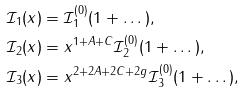Convert formula to latex. <formula><loc_0><loc_0><loc_500><loc_500>\mathcal { I } _ { 1 } ( x ) & = \mathcal { I } _ { 1 } ^ { ( 0 ) } ( 1 + \dots ) , \\ \mathcal { I } _ { 2 } ( x ) & = x ^ { 1 + A + C } \mathcal { I } _ { 2 } ^ { ( 0 ) } ( 1 + \dots ) , \\ \mathcal { I } _ { 3 } ( x ) & = x ^ { 2 + 2 A + 2 C + 2 g } \mathcal { I } _ { 3 } ^ { ( 0 ) } ( 1 + \dots ) ,</formula> 